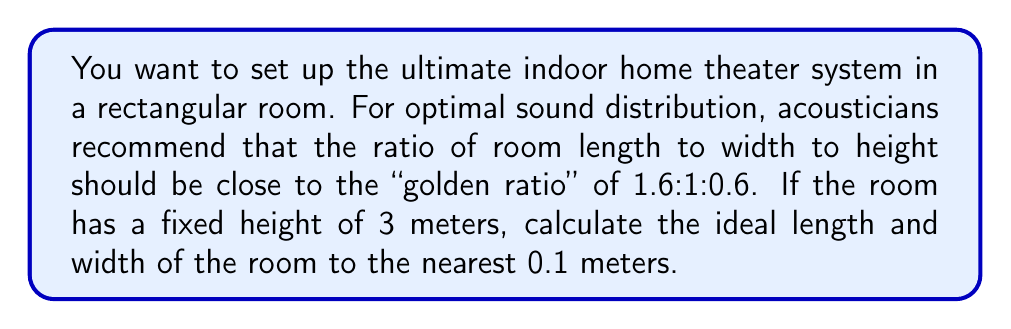Give your solution to this math problem. Let's approach this step-by-step:

1) The golden ratio for room dimensions is 1.6 : 1 : 0.6 for length : width : height.

2) We're given that the height is fixed at 3 meters. Let's call this $h$.

3) If we consider the width as our base unit (1), then:
   Height = $0.6 \times$ width
   Length = $1.6 \times$ width

4) We can set up an equation based on the known height:

   $$3 = 0.6w$$

   Where $w$ is the width.

5) Solving for $w$:

   $$w = \frac{3}{0.6} = 5$$

6) Now that we know the width, we can calculate the length:

   $$l = 1.6w = 1.6 \times 5 = 8$$

7) Therefore, the ideal dimensions are:
   Length: 8 meters
   Width: 5 meters
   Height: 3 meters (given)

8) Rounding to the nearest 0.1 meters doesn't change these values.

To verify:
- Ratio of length to width: $8/5 = 1.6$
- Ratio of length to height: $8/3 \approx 2.67$
- Ratio of width to height: $5/3 \approx 1.67$

These ratios are consistent with the 1.6:1:0.6 golden ratio.
Answer: Length: 8.0 meters, Width: 5.0 meters 